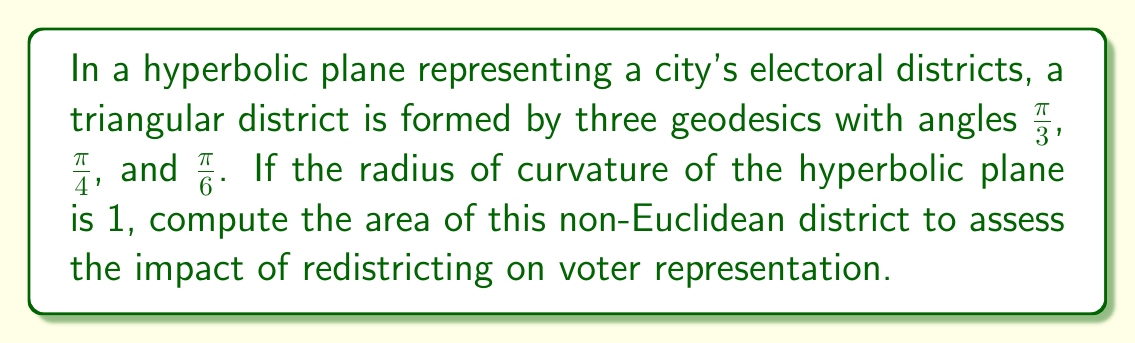Show me your answer to this math problem. To solve this problem, we'll use the Gauss-Bonnet formula for hyperbolic triangles:

1) The Gauss-Bonnet formula states that for a hyperbolic triangle with angles $\alpha$, $\beta$, and $\gamma$:

   $$A = \pi - (\alpha + \beta + \gamma)$$

   where $A$ is the area of the triangle and the radius of curvature is 1.

2) In our case, we have:
   $\alpha = \frac{\pi}{3}$, $\beta = \frac{\pi}{4}$, and $\gamma = \frac{\pi}{6}$

3) Substituting these values into the formula:

   $$A = \pi - (\frac{\pi}{3} + \frac{\pi}{4} + \frac{\pi}{6})$$

4) Simplify the right side:
   $$A = \pi - (\frac{4\pi}{12} + \frac{3\pi}{12} + \frac{2\pi}{12})$$
   $$A = \pi - \frac{9\pi}{12}$$

5) Perform the subtraction:
   $$A = \frac{12\pi}{12} - \frac{9\pi}{12} = \frac{3\pi}{12} = \frac{\pi}{4}$$

Therefore, the area of the hyperbolic triangular district is $\frac{\pi}{4}$ square units.
Answer: $\frac{\pi}{4}$ square units 